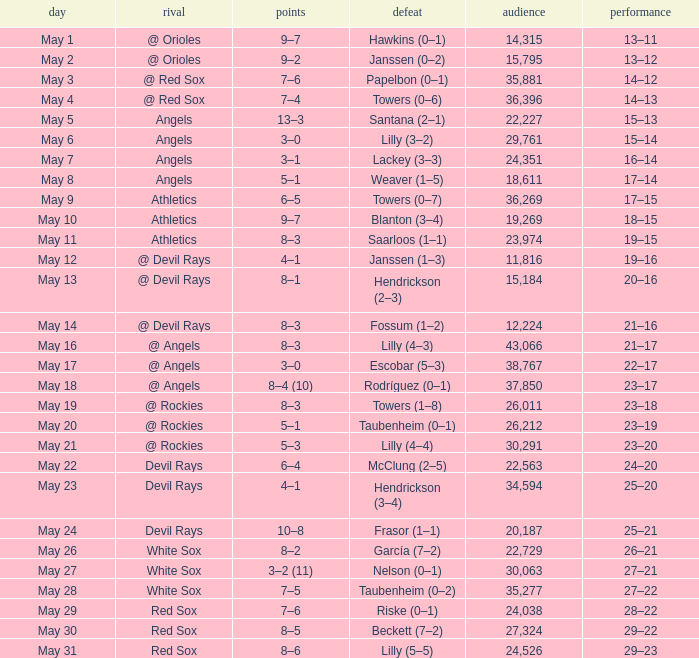What was the average attendance for games with a loss of papelbon (0–1)? 35881.0. 